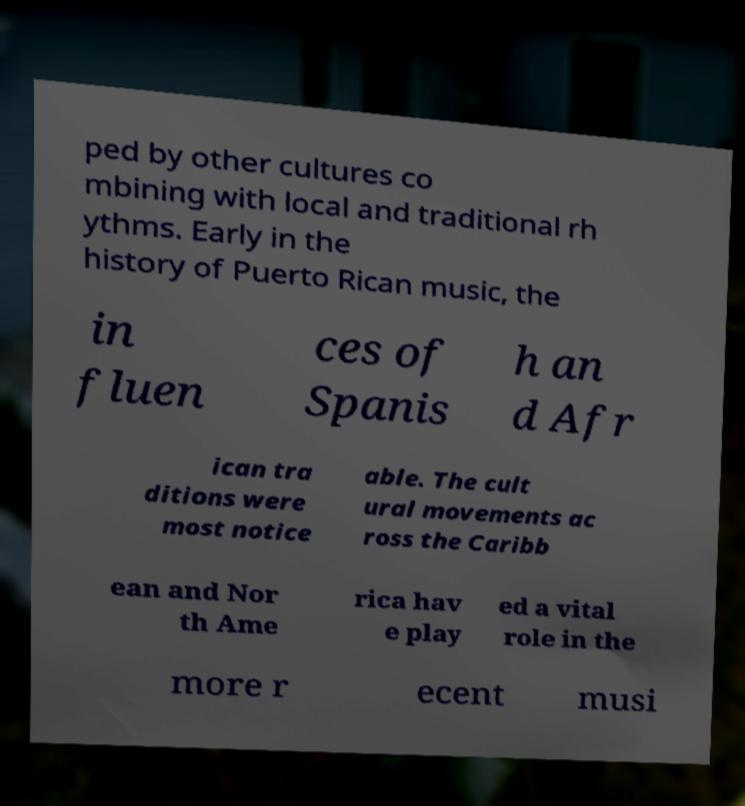Please identify and transcribe the text found in this image. ped by other cultures co mbining with local and traditional rh ythms. Early in the history of Puerto Rican music, the in fluen ces of Spanis h an d Afr ican tra ditions were most notice able. The cult ural movements ac ross the Caribb ean and Nor th Ame rica hav e play ed a vital role in the more r ecent musi 